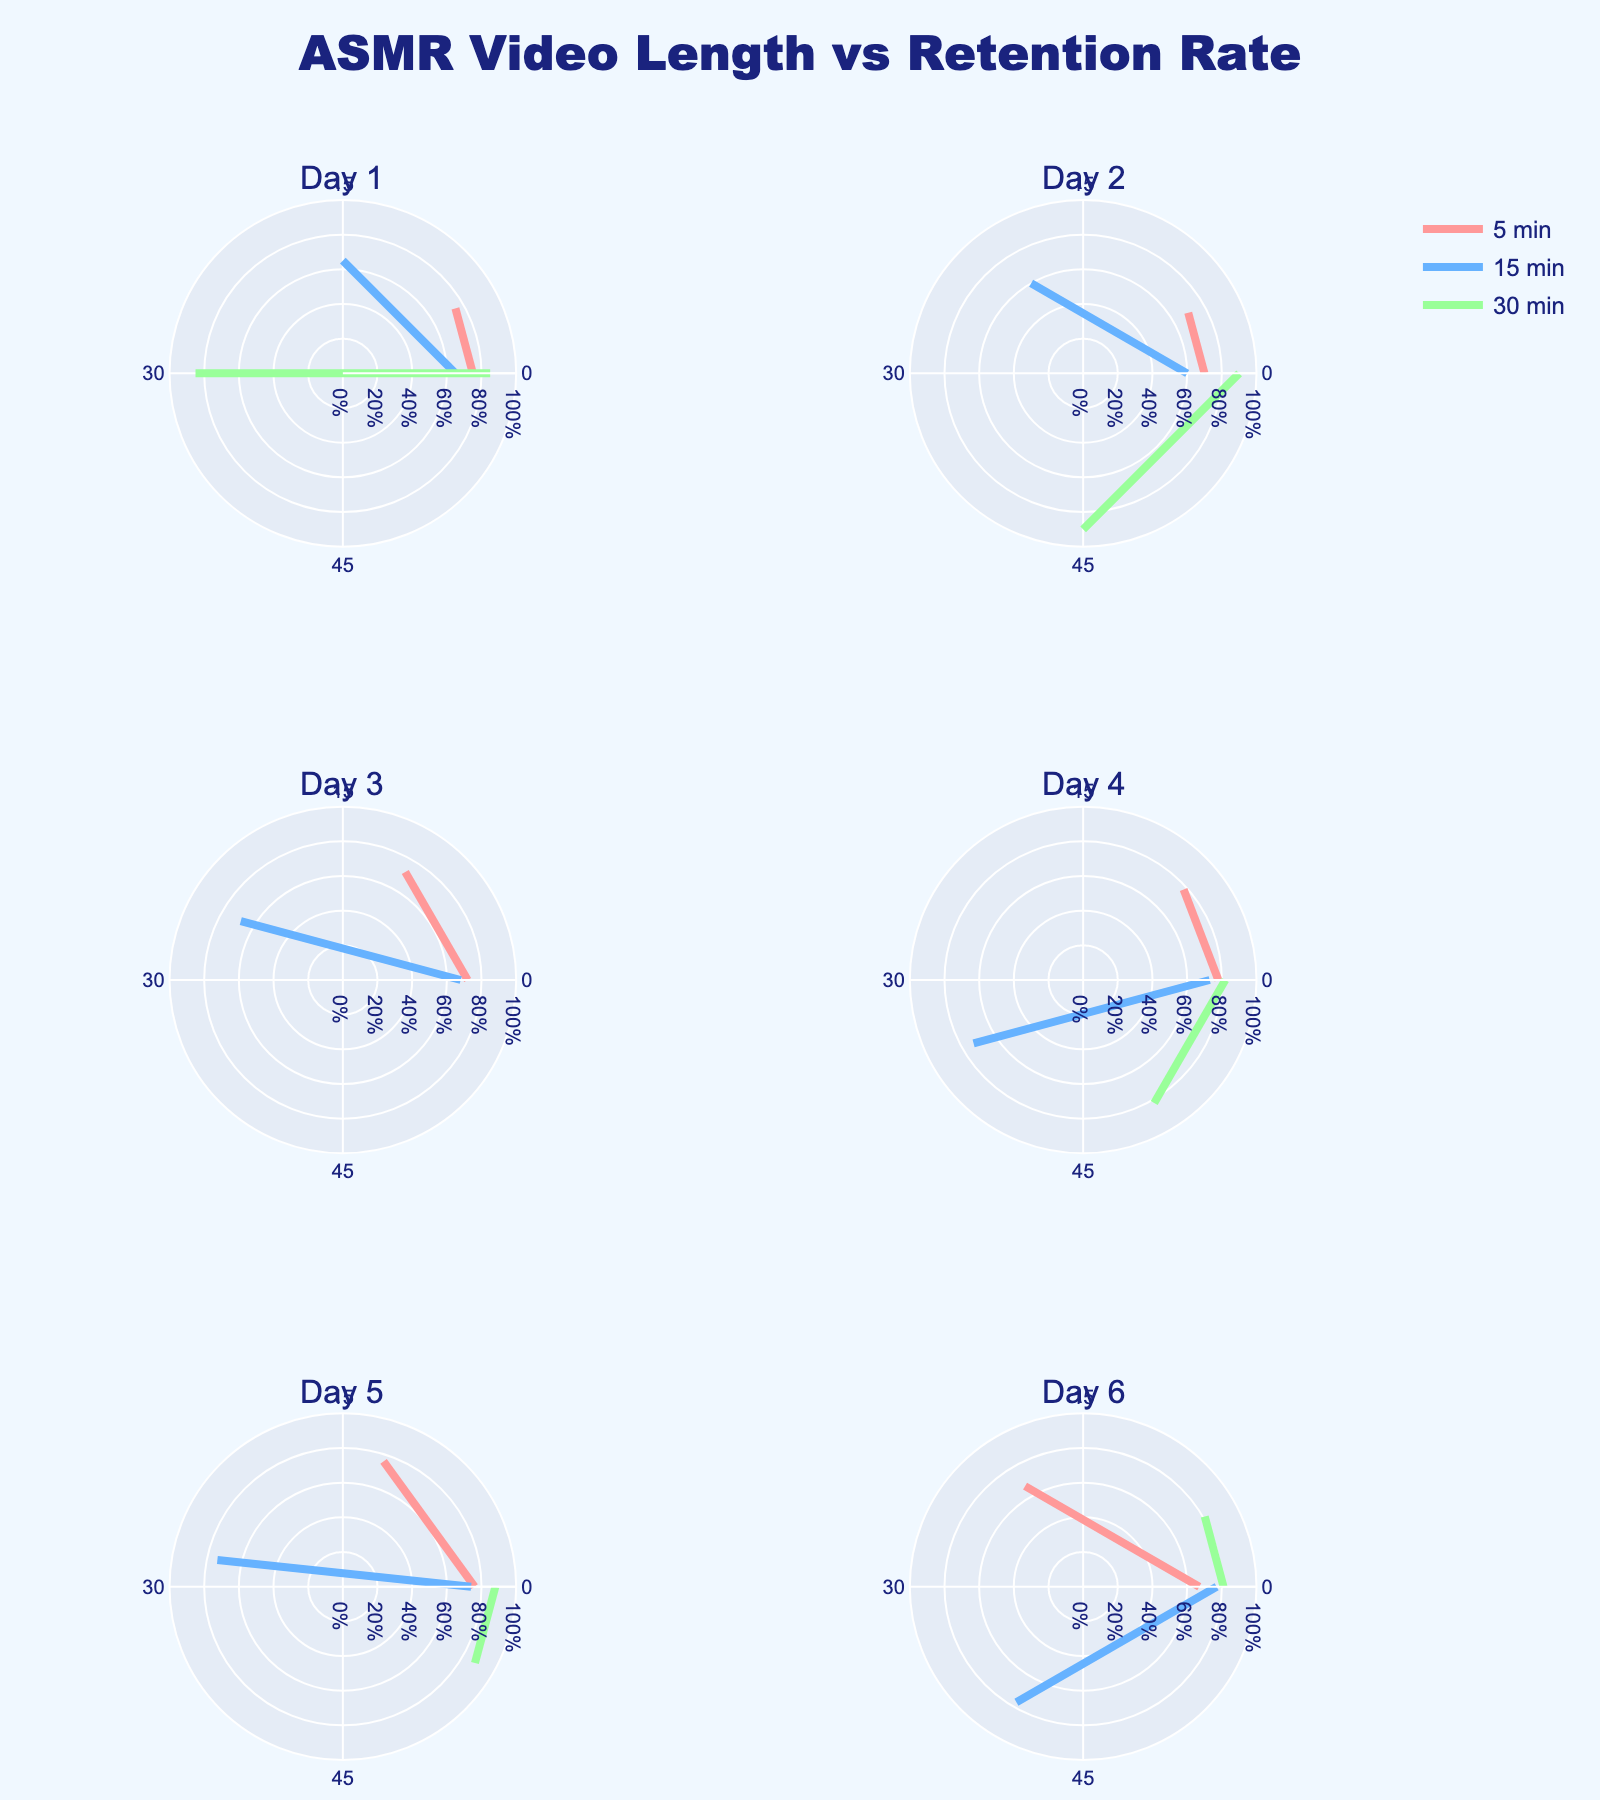What is the title of the figure? The title of the figure is usually placed at the top center. In this figure, it is displayed as "ASMR Video Length vs Retention Rate".
Answer: "ASMR Video Length vs Retention Rate" How many subplots are there in the figure? There are 6 subplot titles visible in the figure arrangement. The subplots are organized in 3 rows and 2 columns. We count them to confirm the total is 6.
Answer: 6 What are the color categories used in the subplots? The rose charts use 3 different colors. These colors are shades of red, blue, and green.
Answer: Red, blue, green Which subplot has the longest video duration? Look at each subplot and identify the maximum marked video length. Subplots represent days, and we look until we find the subplot with the most extended duration. Subplot for Day 6 has a 65-minute video.
Answer: Day 6 Which day shows the highest retention rate? We need to compare each subplot to find the highest retention rate. We observe retention rates across all subplots and see that 90% retention is the highest shown in Day 2.
Answer: Day 2 What is the average retention rate of videos on Day 1? For Day 1, add up the retention rates (75%, 65%, 85%) and then divide by the number of data points, which are 3. The calculation is (75 + 65 + 85) / 3 = 75.
Answer: 75% How does the retention rate of the 30-minute video on Day 3 compare to the 60-minute video? We look at the retention rates for the 30-minute (80%) and the 60-minute (80%) videos on Day 3. Both the retention rates are 80%. They are equal.
Answer: They are equal What is the retention rate trend for longer videos (above 45 minutes) across the days? We observe retention rates for videos longer than 45 minutes across the days. The rates are 90%, 85%, 82%, 88%, 84%, 79%, 69%, 87%, and 86%. It indicates a generally high retention rate for longer videos.
Answer: Generally high On which day is the retention highest for a video shorter than 10 minutes? We look at subplots for videos shorter than 10 minutes across the days. We find that Day 4 has a 7-minute video with a retention rate of 78%, which is the highest.
Answer: Day 4 What is the retention rate pattern for 50-minute videos from Day 5 to Day 30? We check the retention rates for 50-minute videos on the relevant days. Retention rates are: Day 6 (82%), Day 7 (84%), Day 11 (87%), Day 12 (85%), Day 13 (85%), Day 17 (88%), Day 19 (84%), Day 25 (86%), Day 30 (88%) showing consistently high retention.
Answer: Consistently high 